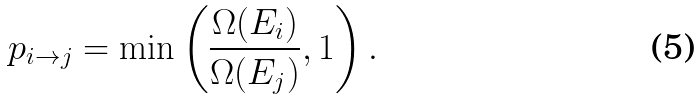<formula> <loc_0><loc_0><loc_500><loc_500>p _ { i \rightarrow j } = \min \left ( \frac { \Omega ( E _ { i } ) } { \Omega ( E _ { j } ) } , 1 \right ) .</formula> 